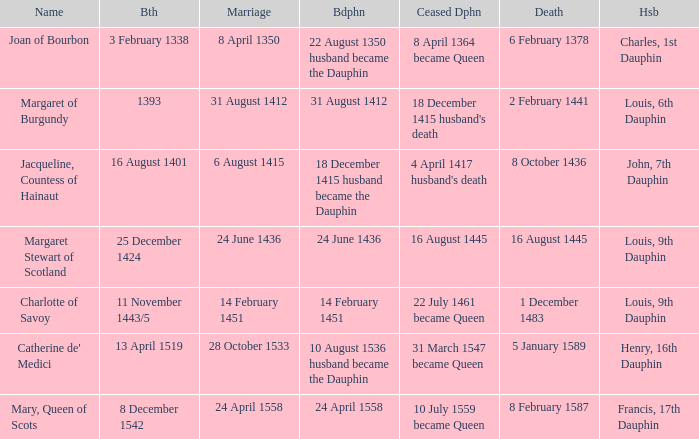When was the death when the birth was 8 december 1542? 8 February 1587. 